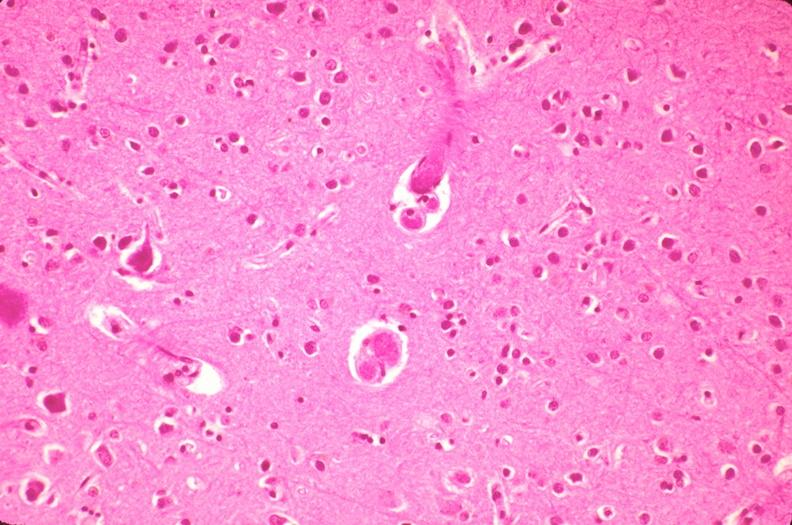s nervous present?
Answer the question using a single word or phrase. Yes 